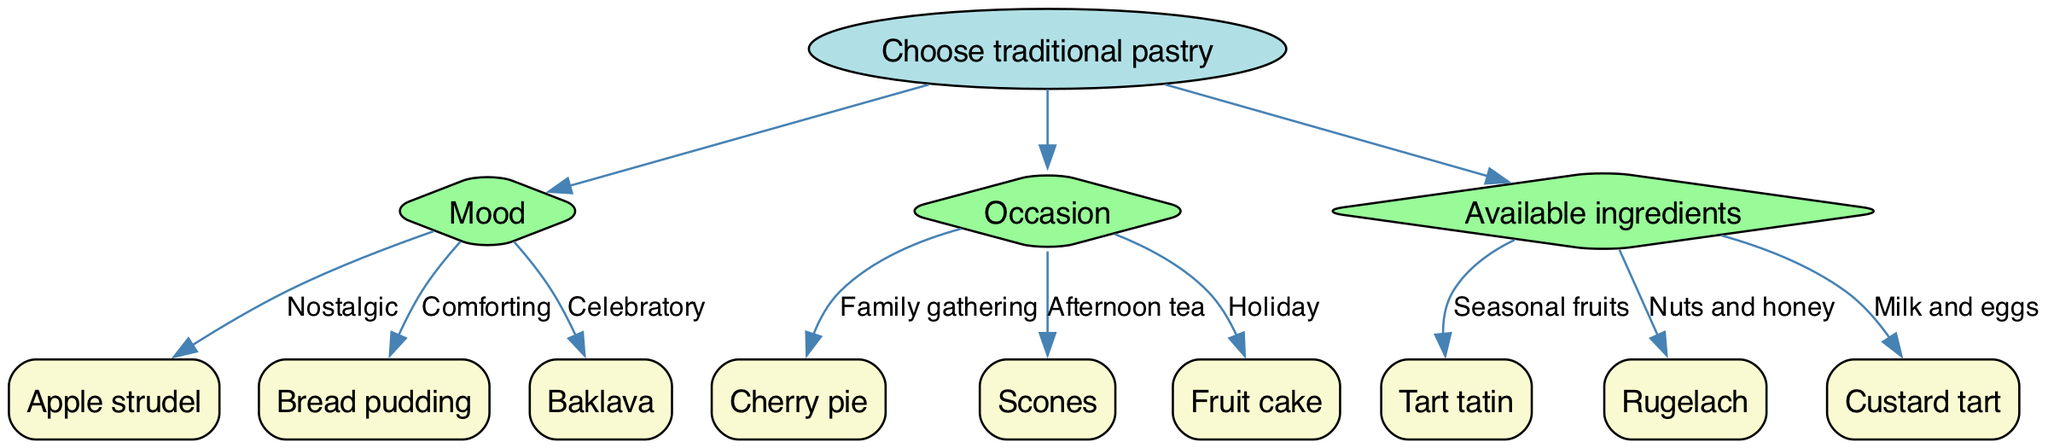What is the root node of the diagram? The root node is labeled "Choose traditional pastry," which serves as the starting point of the decision tree.
Answer: Choose traditional pastry How many branches are there? There are three branches in the decision tree: Mood, Occasion, and Available ingredients. Each branch leads to different choices for selecting a pastry.
Answer: 3 What traditional pastry is associated with the mood "Comforting"? According to the diagram, the pastry linked to the mood "Comforting" is "Bread pudding." This is stated under the Mood branch options.
Answer: Bread pudding What occasion is linked to the pastry "Scones"? The pastry "Scones" is associated with the occasion "Afternoon tea," as shown in the Occasion branch of the diagram.
Answer: Afternoon tea If the available ingredients are "Seasonal fruits", which pastry should be chosen? The diagram indicates that if "Seasonal fruits" are available, the appropriate pastry to choose is "Tart tatin," as specified under the Available ingredients branch.
Answer: Tart tatin Which pastry would you select for a "Family gathering"? The decision tree shows that for a "Family gathering," the suggested pastry is "Cherry pie," found in the Occasion branch.
Answer: Cherry pie What is the relationship between "Nuts and honey" and a traditional pastry? The relationship is that "Nuts and honey" lead to the pastry "Rugelach," illustrating a connection between available ingredients and the resulting pastry choice in the Available ingredients branch.
Answer: Rugelach Which mood is linked to "Baklava"? The mood associated with "Baklava" is "Celebratory," as indicated in the Mood branch of the decision tree.
Answer: Celebratory What type of pastry belongs to the node with the label "Custard tart"? The pastry "Custard tart" is linked to the available ingredients of "Milk and eggs," showing its direct connection in the Available ingredients branch.
Answer: Milk and eggs 